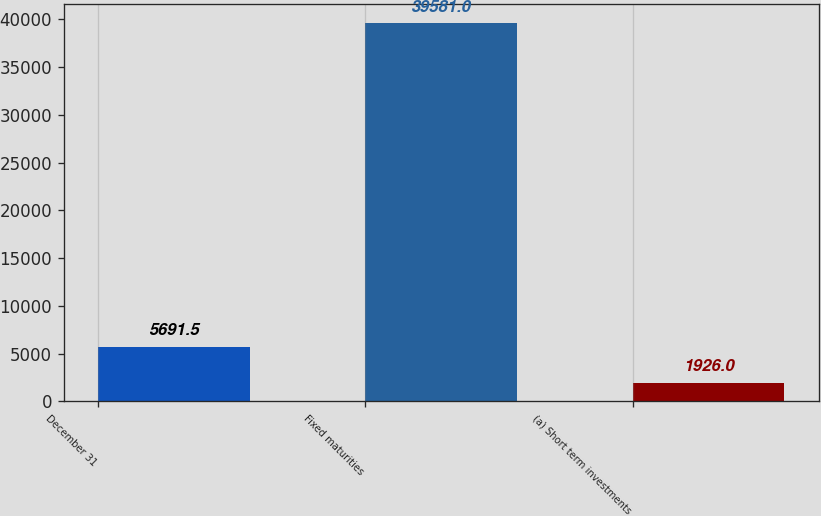<chart> <loc_0><loc_0><loc_500><loc_500><bar_chart><fcel>December 31<fcel>Fixed maturities<fcel>(a) Short term investments<nl><fcel>5691.5<fcel>39581<fcel>1926<nl></chart> 